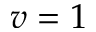<formula> <loc_0><loc_0><loc_500><loc_500>v = 1</formula> 